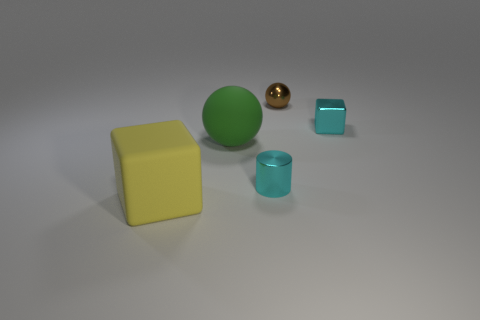Add 4 green rubber balls. How many objects exist? 9 Subtract all cylinders. How many objects are left? 4 Add 5 small shiny cubes. How many small shiny cubes exist? 6 Subtract 1 cyan cylinders. How many objects are left? 4 Subtract all brown shiny things. Subtract all green rubber blocks. How many objects are left? 4 Add 1 yellow cubes. How many yellow cubes are left? 2 